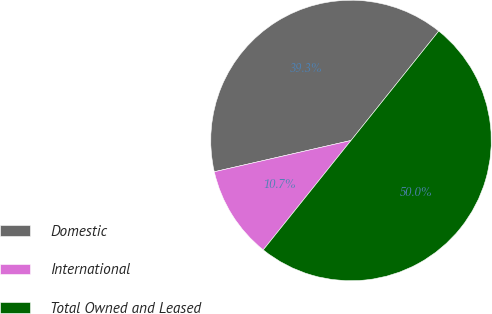Convert chart to OTSL. <chart><loc_0><loc_0><loc_500><loc_500><pie_chart><fcel>Domestic<fcel>International<fcel>Total Owned and Leased<nl><fcel>39.34%<fcel>10.66%<fcel>50.0%<nl></chart> 